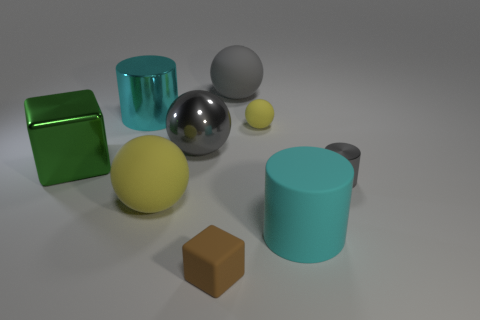Could you describe the lighting and shadows seen in the scene? The image seems to be lit by a soft, diffused light source coming from the top, creating subtle shadows to the right of the objects. The lighting provides a clear definition of the shapes, and the shadows contribute to the depth and realism in the scene. 